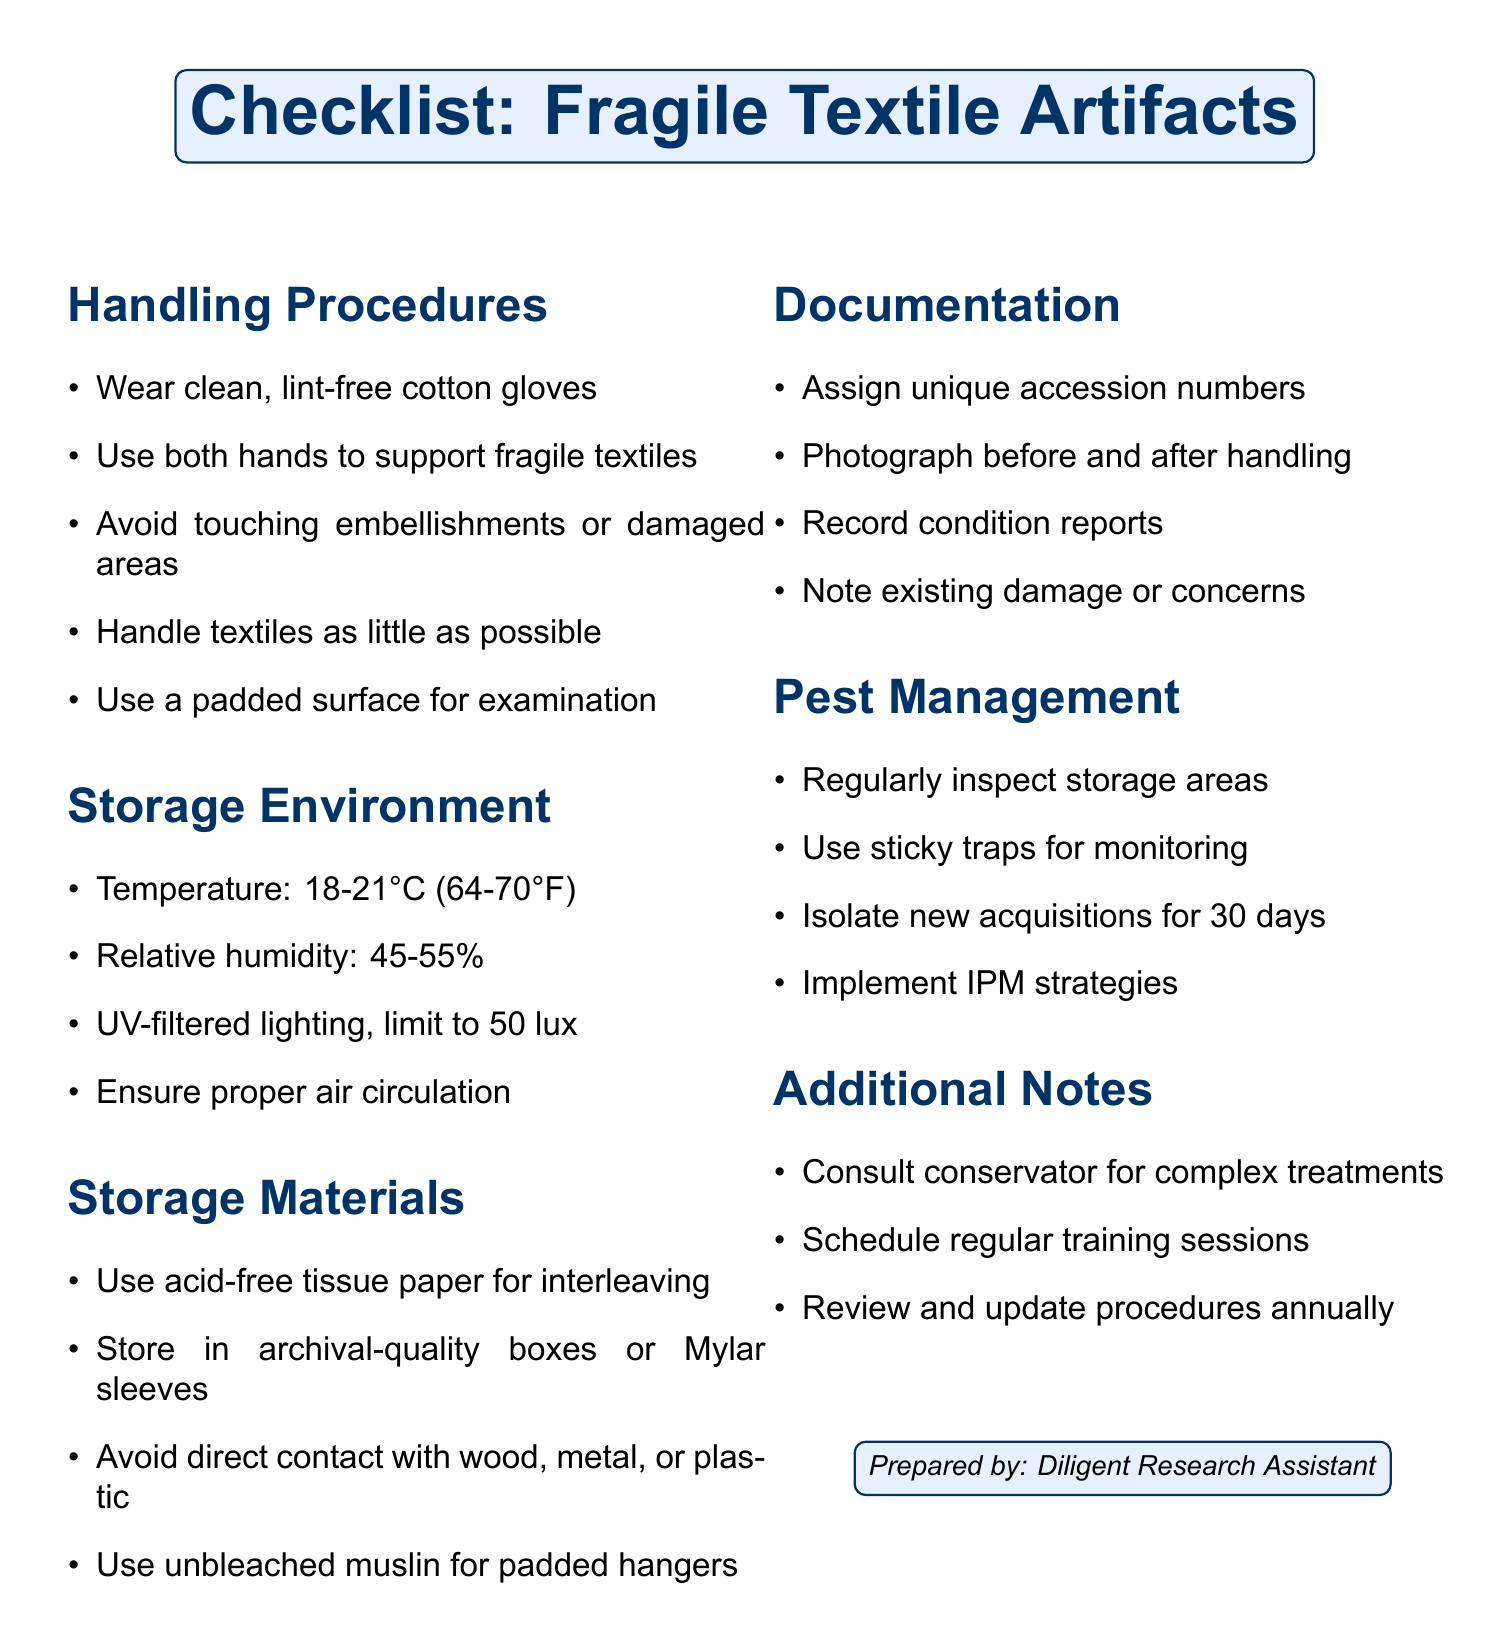What should be worn when handling textiles? The document states that clean, lint-free cotton gloves should be worn when handling textiles to protect them.
Answer: Clean, lint-free cotton gloves What is the recommended temperature range for storing textiles? The document specifies that the temperature should be maintained between 18-21 degrees Celsius.
Answer: 18-21 degrees Celsius What type of paper should be used for interleaving? According to the document, acid-free tissue paper is recommended for interleaving textiles to prevent deterioration.
Answer: Acid-free tissue paper How often should storage areas be inspected for pests? The document advises regular inspections of storage areas to monitor for signs of pests.
Answer: Regularly What additional steps should be taken for new acquisitions? The document mentions isolating new acquisitions for at least 30 days as a precautionary measure against pests.
Answer: Isolate for at least 30 days What unique numbers are assigned to artifacts? The document states that unique accession numbers are assigned to each artifact for documentation purposes.
Answer: Unique accession numbers What should be noted in condition reports? The document emphasizes the importance of noting any existing damage or areas of concern in the condition reports.
Answer: Existing damage or areas of concern How frequently should procedures be reviewed? The document specifies that procedures should be reviewed and updated annually based on current best practices.
Answer: Annually What should be used to cover padded hangers? The document indicates that unbleached muslin should be used to cover padded hangers for costume storage.
Answer: Unbleached muslin 